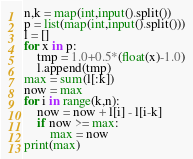Convert code to text. <code><loc_0><loc_0><loc_500><loc_500><_Python_>n,k = map(int,input().split())
p = list(map(int,input().split()))
l = []
for x in p:
    tmp = 1.0+0.5*(float(x)-1.0)
    l.append(tmp)
max = sum(l[:k])
now = max
for i in range(k,n):
    now = now + l[i] - l[i-k]
    if now >= max:
        max = now
print(max)</code> 